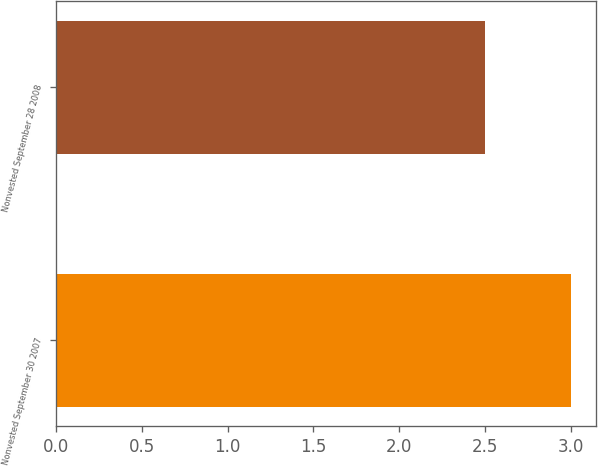Convert chart to OTSL. <chart><loc_0><loc_0><loc_500><loc_500><bar_chart><fcel>Nonvested September 30 2007<fcel>Nonvested September 28 2008<nl><fcel>3<fcel>2.5<nl></chart> 